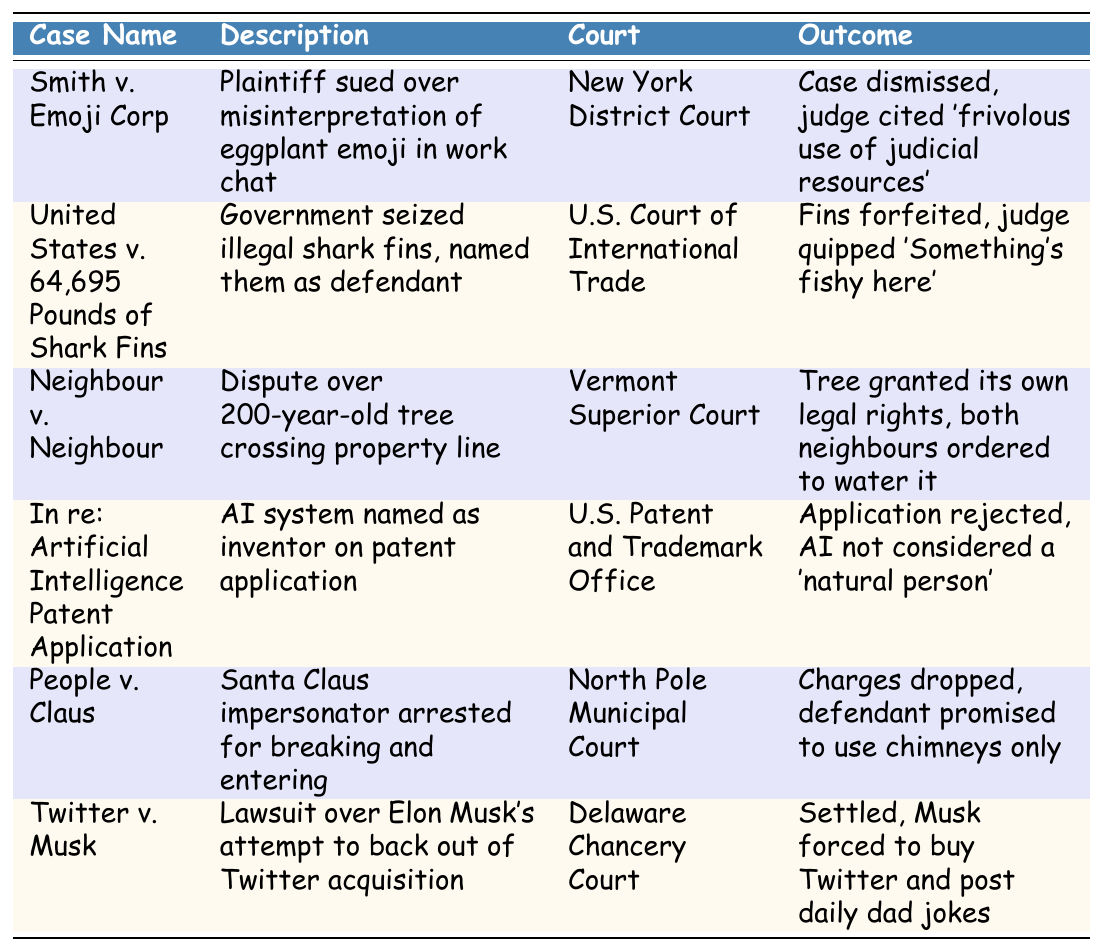What is the outcome of the case "Smith v. Emoji Corp"? The table specifies that the outcome of "Smith v. Emoji Corp" is that the case was dismissed, with the judge citing a 'frivolous use of judicial resources'.
Answer: Case dismissed Which court handled the case involving "United States v. 64,695 Pounds of Shark Fins"? According to the table, the U.S. Court of International Trade was the court that handled the case involving "United States v. 64,695 Pounds of Shark Fins".
Answer: U.S. Court of International Trade Was the AI system considered a natural person in the "In re: Artificial Intelligence Patent Application" case? The outcome indicates that the AI was not considered a 'natural person', according to the decision stated in the table.
Answer: No How many cases involve disputes between individuals (not organizations)? The table shows two cases: "Neighbour v. Neighbour" and "People v. Claus" involve disputes between individuals. This can be counted directly from the descriptions.
Answer: 2 In what court was the lawsuit "Twitter v. Musk" settled? The table indicates that the lawsuit "Twitter v. Musk" was settled in the Delaware Chancery Court.
Answer: Delaware Chancery Court What was the common theme in the outcomes of the unusual legal cases presented? A closer look at the outcomes reveals that many of the cases include humorous or unusual rulings. For example, a tree was granted its own legal rights, and there were witty comments by the judge.
Answer: Humorous or unusual rulings Which case involved a legal issue regarding an emoji? From the table, the case "Smith v. Emoji Corp" involved a legal issue over the misinterpretation of an eggplant emoji in a work chat.
Answer: Smith v. Emoji Corp Did the court recognize the tree's rights in "Neighbour v. Neighbour"? Yes, according to the table, the court granted the tree its own legal rights.
Answer: Yes What kind of punishment was Elon Musk given in the "Twitter v. Musk" case? The outcome states that Elon Musk was forced to buy Twitter and post daily dad jokes, which showcases a light-hearted punishment.
Answer: Forced to buy Twitter and post daily dad jokes How many cases were decided in favor of the plaintiff in the table? The table shows that most cases were either dismissed or settled without a clear 'win' for the plaintiff, therefore we observe that none had a definitive 'win' outcome.
Answer: 0 Which legal case mentions a Santa Claus impersonator? The case "People v. Claus" mentions a Santa Claus impersonator who was arrested for breaking and entering.
Answer: People v. Claus 